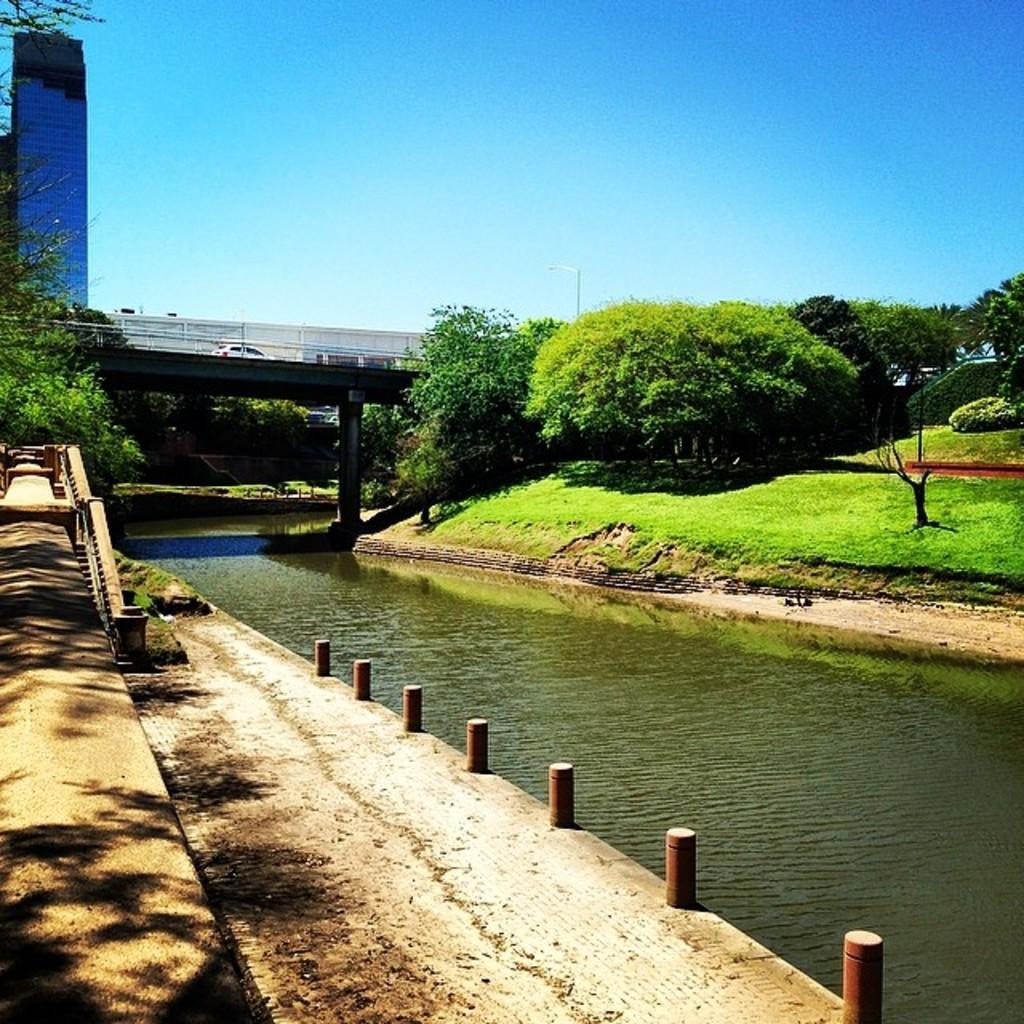Can you describe this image briefly? In this image at the bottom, there is water. On the right, there are trees, grass, bridge, car, sky. On the left there are buildings, trees, grass. 